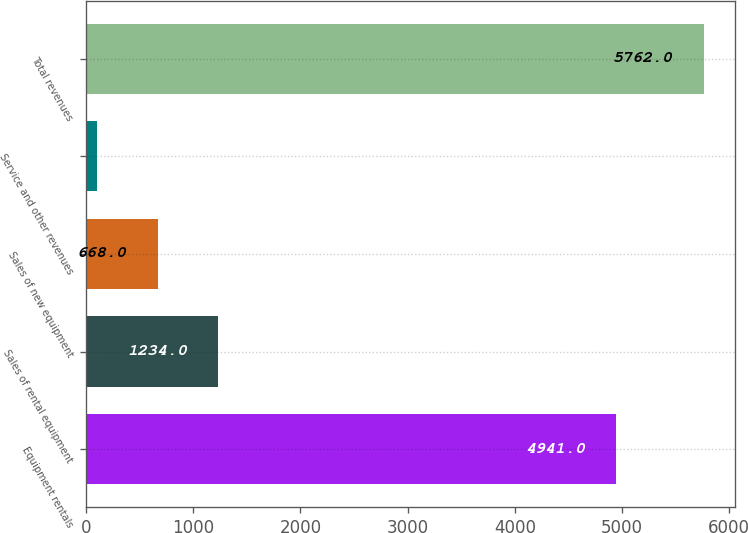<chart> <loc_0><loc_0><loc_500><loc_500><bar_chart><fcel>Equipment rentals<fcel>Sales of rental equipment<fcel>Sales of new equipment<fcel>Service and other revenues<fcel>Total revenues<nl><fcel>4941<fcel>1234<fcel>668<fcel>102<fcel>5762<nl></chart> 